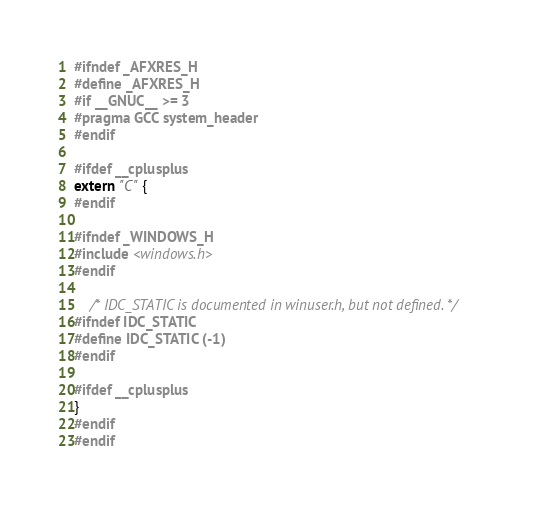<code> <loc_0><loc_0><loc_500><loc_500><_C_>#ifndef _AFXRES_H
#define _AFXRES_H
#if __GNUC__ >= 3
#pragma GCC system_header
#endif

#ifdef __cplusplus
extern "C" {
#endif

#ifndef _WINDOWS_H
#include <windows.h>
#endif

    /* IDC_STATIC is documented in winuser.h, but not defined. */
#ifndef IDC_STATIC
#define IDC_STATIC (-1)
#endif

#ifdef __cplusplus
}
#endif
#endif
</code> 